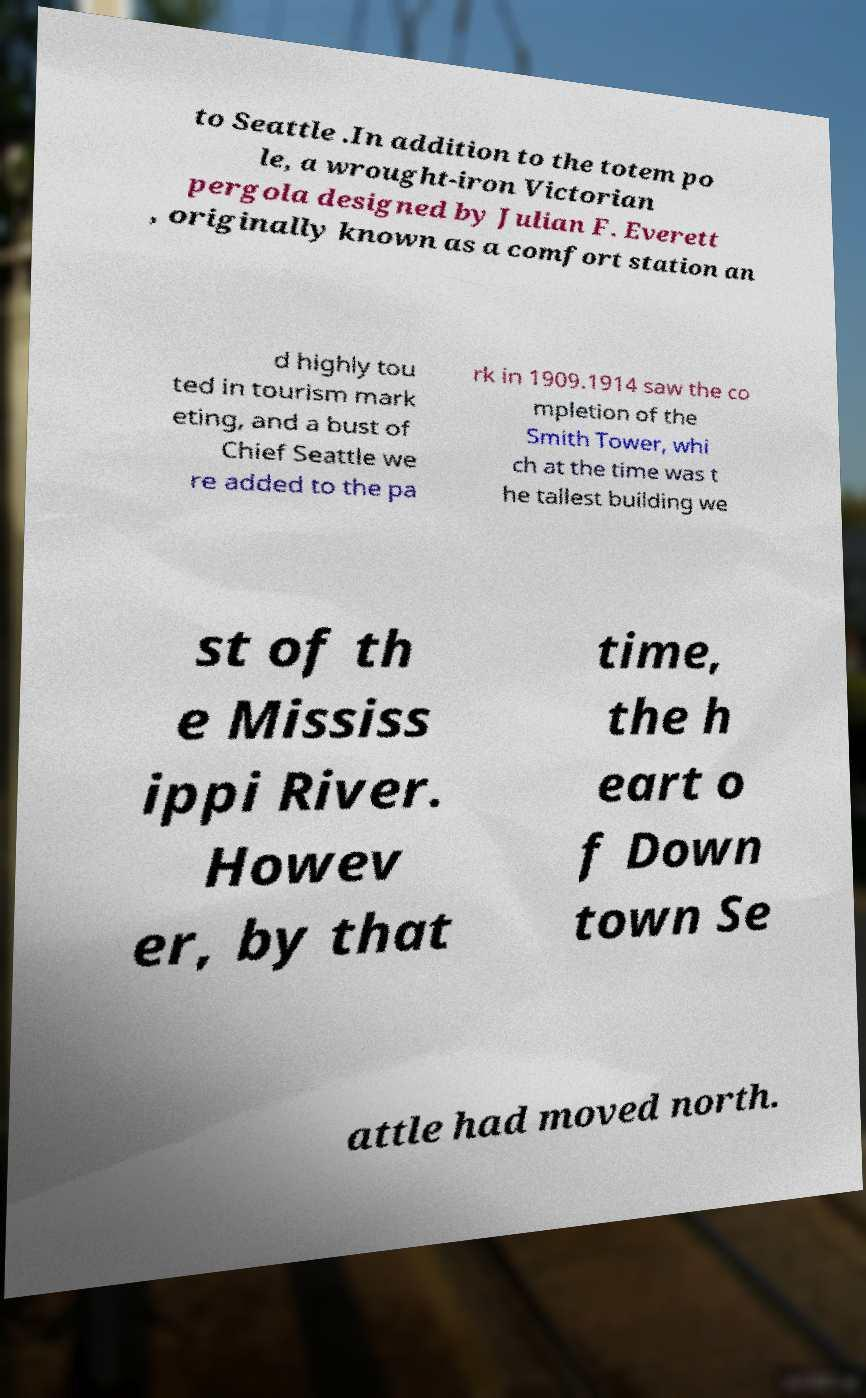Could you assist in decoding the text presented in this image and type it out clearly? to Seattle .In addition to the totem po le, a wrought-iron Victorian pergola designed by Julian F. Everett , originally known as a comfort station an d highly tou ted in tourism mark eting, and a bust of Chief Seattle we re added to the pa rk in 1909.1914 saw the co mpletion of the Smith Tower, whi ch at the time was t he tallest building we st of th e Mississ ippi River. Howev er, by that time, the h eart o f Down town Se attle had moved north. 